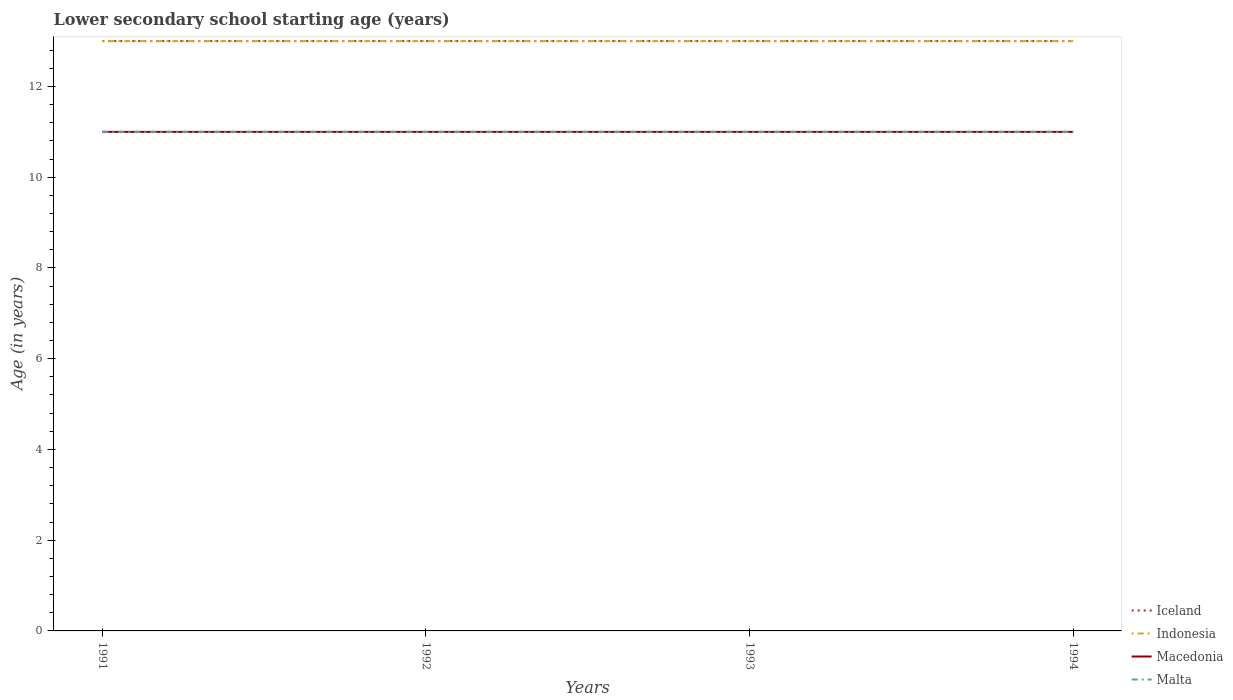How many different coloured lines are there?
Your answer should be compact. 4. Does the line corresponding to Malta intersect with the line corresponding to Macedonia?
Your answer should be compact. Yes. Is the number of lines equal to the number of legend labels?
Your answer should be very brief. Yes. Across all years, what is the maximum lower secondary school starting age of children in Iceland?
Your response must be concise. 13. In which year was the lower secondary school starting age of children in Macedonia maximum?
Offer a very short reply. 1991. What is the difference between the highest and the lowest lower secondary school starting age of children in Iceland?
Ensure brevity in your answer.  0. Is the lower secondary school starting age of children in Macedonia strictly greater than the lower secondary school starting age of children in Iceland over the years?
Your response must be concise. Yes. How many years are there in the graph?
Ensure brevity in your answer.  4. What is the difference between two consecutive major ticks on the Y-axis?
Your answer should be compact. 2. Are the values on the major ticks of Y-axis written in scientific E-notation?
Provide a succinct answer. No. Does the graph contain any zero values?
Keep it short and to the point. No. How many legend labels are there?
Your answer should be very brief. 4. What is the title of the graph?
Keep it short and to the point. Lower secondary school starting age (years). Does "New Caledonia" appear as one of the legend labels in the graph?
Ensure brevity in your answer.  No. What is the label or title of the Y-axis?
Your answer should be compact. Age (in years). What is the Age (in years) in Iceland in 1991?
Offer a very short reply. 13. What is the Age (in years) of Malta in 1991?
Keep it short and to the point. 11. What is the Age (in years) in Iceland in 1992?
Keep it short and to the point. 13. What is the Age (in years) in Indonesia in 1992?
Your response must be concise. 13. What is the Age (in years) in Iceland in 1993?
Offer a terse response. 13. What is the Age (in years) in Indonesia in 1993?
Your response must be concise. 13. What is the Age (in years) in Malta in 1994?
Make the answer very short. 11. Across all years, what is the maximum Age (in years) of Iceland?
Provide a succinct answer. 13. Across all years, what is the maximum Age (in years) of Macedonia?
Ensure brevity in your answer.  11. Across all years, what is the maximum Age (in years) of Malta?
Offer a very short reply. 11. Across all years, what is the minimum Age (in years) in Indonesia?
Offer a terse response. 13. Across all years, what is the minimum Age (in years) in Macedonia?
Your response must be concise. 11. Across all years, what is the minimum Age (in years) of Malta?
Provide a short and direct response. 11. What is the total Age (in years) of Iceland in the graph?
Your response must be concise. 52. What is the total Age (in years) in Indonesia in the graph?
Your answer should be compact. 52. What is the total Age (in years) of Malta in the graph?
Your response must be concise. 44. What is the difference between the Age (in years) of Macedonia in 1991 and that in 1993?
Keep it short and to the point. 0. What is the difference between the Age (in years) of Iceland in 1991 and that in 1994?
Your answer should be very brief. 0. What is the difference between the Age (in years) of Malta in 1991 and that in 1994?
Offer a terse response. 0. What is the difference between the Age (in years) of Iceland in 1992 and that in 1993?
Your answer should be compact. 0. What is the difference between the Age (in years) in Indonesia in 1992 and that in 1993?
Your answer should be compact. 0. What is the difference between the Age (in years) in Malta in 1992 and that in 1993?
Your answer should be compact. 0. What is the difference between the Age (in years) of Iceland in 1992 and that in 1994?
Provide a short and direct response. 0. What is the difference between the Age (in years) in Indonesia in 1992 and that in 1994?
Offer a terse response. 0. What is the difference between the Age (in years) of Indonesia in 1993 and that in 1994?
Your answer should be very brief. 0. What is the difference between the Age (in years) in Macedonia in 1993 and that in 1994?
Ensure brevity in your answer.  0. What is the difference between the Age (in years) in Iceland in 1991 and the Age (in years) in Indonesia in 1992?
Offer a very short reply. 0. What is the difference between the Age (in years) of Iceland in 1991 and the Age (in years) of Macedonia in 1992?
Provide a succinct answer. 2. What is the difference between the Age (in years) in Indonesia in 1991 and the Age (in years) in Malta in 1992?
Make the answer very short. 2. What is the difference between the Age (in years) in Macedonia in 1991 and the Age (in years) in Malta in 1992?
Provide a succinct answer. 0. What is the difference between the Age (in years) in Iceland in 1991 and the Age (in years) in Indonesia in 1993?
Give a very brief answer. 0. What is the difference between the Age (in years) of Iceland in 1991 and the Age (in years) of Malta in 1994?
Your answer should be very brief. 2. What is the difference between the Age (in years) of Indonesia in 1991 and the Age (in years) of Malta in 1994?
Make the answer very short. 2. What is the difference between the Age (in years) in Macedonia in 1991 and the Age (in years) in Malta in 1994?
Your response must be concise. 0. What is the difference between the Age (in years) of Iceland in 1992 and the Age (in years) of Indonesia in 1993?
Provide a short and direct response. 0. What is the difference between the Age (in years) of Iceland in 1992 and the Age (in years) of Macedonia in 1993?
Your answer should be very brief. 2. What is the difference between the Age (in years) in Iceland in 1992 and the Age (in years) in Indonesia in 1994?
Offer a very short reply. 0. What is the difference between the Age (in years) in Iceland in 1992 and the Age (in years) in Malta in 1994?
Your response must be concise. 2. What is the difference between the Age (in years) in Indonesia in 1992 and the Age (in years) in Macedonia in 1994?
Provide a succinct answer. 2. What is the difference between the Age (in years) of Iceland in 1993 and the Age (in years) of Malta in 1994?
Keep it short and to the point. 2. What is the difference between the Age (in years) in Indonesia in 1993 and the Age (in years) in Macedonia in 1994?
Give a very brief answer. 2. What is the difference between the Age (in years) in Indonesia in 1993 and the Age (in years) in Malta in 1994?
Your response must be concise. 2. What is the average Age (in years) in Indonesia per year?
Ensure brevity in your answer.  13. What is the average Age (in years) of Macedonia per year?
Provide a short and direct response. 11. In the year 1991, what is the difference between the Age (in years) in Iceland and Age (in years) in Indonesia?
Your response must be concise. 0. In the year 1991, what is the difference between the Age (in years) of Iceland and Age (in years) of Macedonia?
Offer a terse response. 2. In the year 1991, what is the difference between the Age (in years) of Iceland and Age (in years) of Malta?
Offer a terse response. 2. In the year 1991, what is the difference between the Age (in years) in Indonesia and Age (in years) in Macedonia?
Offer a terse response. 2. In the year 1992, what is the difference between the Age (in years) in Iceland and Age (in years) in Malta?
Provide a short and direct response. 2. In the year 1992, what is the difference between the Age (in years) of Indonesia and Age (in years) of Macedonia?
Keep it short and to the point. 2. In the year 1992, what is the difference between the Age (in years) of Indonesia and Age (in years) of Malta?
Provide a succinct answer. 2. In the year 1992, what is the difference between the Age (in years) of Macedonia and Age (in years) of Malta?
Ensure brevity in your answer.  0. In the year 1993, what is the difference between the Age (in years) of Iceland and Age (in years) of Indonesia?
Ensure brevity in your answer.  0. In the year 1993, what is the difference between the Age (in years) in Indonesia and Age (in years) in Macedonia?
Give a very brief answer. 2. In the year 1993, what is the difference between the Age (in years) of Indonesia and Age (in years) of Malta?
Your answer should be compact. 2. In the year 1993, what is the difference between the Age (in years) of Macedonia and Age (in years) of Malta?
Give a very brief answer. 0. In the year 1994, what is the difference between the Age (in years) in Iceland and Age (in years) in Macedonia?
Keep it short and to the point. 2. In the year 1994, what is the difference between the Age (in years) in Iceland and Age (in years) in Malta?
Provide a succinct answer. 2. In the year 1994, what is the difference between the Age (in years) in Indonesia and Age (in years) in Macedonia?
Offer a very short reply. 2. In the year 1994, what is the difference between the Age (in years) in Indonesia and Age (in years) in Malta?
Give a very brief answer. 2. What is the ratio of the Age (in years) of Iceland in 1991 to that in 1992?
Make the answer very short. 1. What is the ratio of the Age (in years) of Indonesia in 1991 to that in 1993?
Make the answer very short. 1. What is the ratio of the Age (in years) of Macedonia in 1991 to that in 1993?
Offer a terse response. 1. What is the ratio of the Age (in years) of Malta in 1991 to that in 1993?
Your answer should be compact. 1. What is the ratio of the Age (in years) of Indonesia in 1991 to that in 1994?
Your response must be concise. 1. What is the ratio of the Age (in years) of Macedonia in 1991 to that in 1994?
Keep it short and to the point. 1. What is the ratio of the Age (in years) in Iceland in 1992 to that in 1993?
Give a very brief answer. 1. What is the ratio of the Age (in years) of Macedonia in 1992 to that in 1994?
Give a very brief answer. 1. What is the ratio of the Age (in years) in Iceland in 1993 to that in 1994?
Your answer should be compact. 1. What is the ratio of the Age (in years) of Macedonia in 1993 to that in 1994?
Provide a short and direct response. 1. What is the difference between the highest and the second highest Age (in years) of Iceland?
Offer a very short reply. 0. What is the difference between the highest and the second highest Age (in years) in Indonesia?
Give a very brief answer. 0. What is the difference between the highest and the second highest Age (in years) of Macedonia?
Your response must be concise. 0. What is the difference between the highest and the lowest Age (in years) of Iceland?
Your answer should be very brief. 0. What is the difference between the highest and the lowest Age (in years) of Macedonia?
Provide a short and direct response. 0. What is the difference between the highest and the lowest Age (in years) in Malta?
Offer a terse response. 0. 